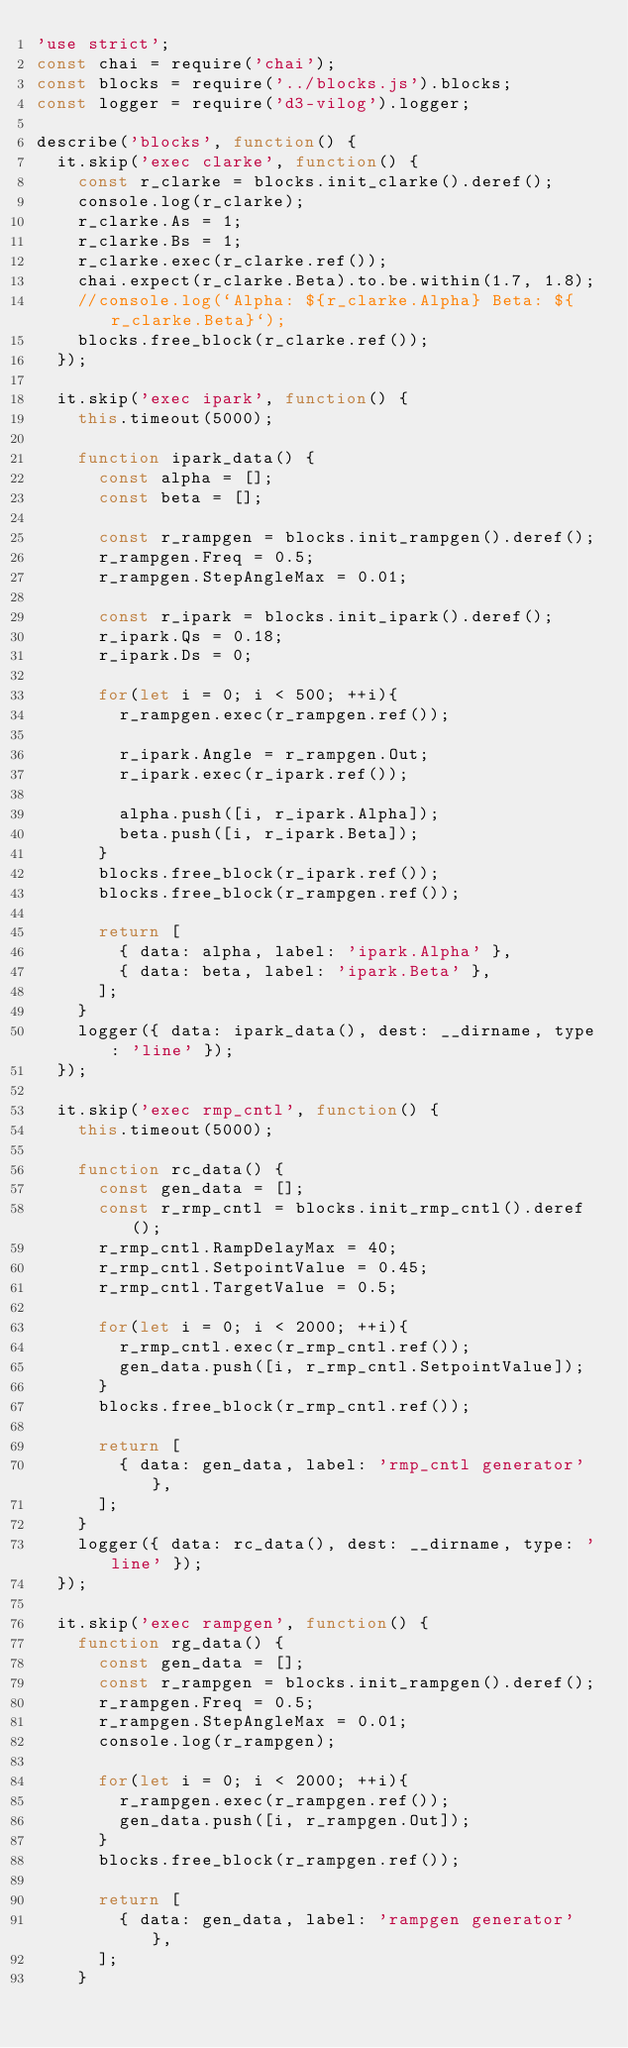<code> <loc_0><loc_0><loc_500><loc_500><_JavaScript_>'use strict';
const chai = require('chai');
const blocks = require('../blocks.js').blocks;
const logger = require('d3-vilog').logger;

describe('blocks', function() {
  it.skip('exec clarke', function() {
    const r_clarke = blocks.init_clarke().deref();
    console.log(r_clarke);
    r_clarke.As = 1;
    r_clarke.Bs = 1;
    r_clarke.exec(r_clarke.ref());
    chai.expect(r_clarke.Beta).to.be.within(1.7, 1.8);
    //console.log(`Alpha: ${r_clarke.Alpha} Beta: ${r_clarke.Beta}`);
    blocks.free_block(r_clarke.ref());
  });

  it.skip('exec ipark', function() {
    this.timeout(5000);

    function ipark_data() {
      const alpha = [];
      const beta = [];

      const r_rampgen = blocks.init_rampgen().deref();
      r_rampgen.Freq = 0.5;
      r_rampgen.StepAngleMax = 0.01;

      const r_ipark = blocks.init_ipark().deref();
      r_ipark.Qs = 0.18;
      r_ipark.Ds = 0;

      for(let i = 0; i < 500; ++i){
        r_rampgen.exec(r_rampgen.ref());

        r_ipark.Angle = r_rampgen.Out;
        r_ipark.exec(r_ipark.ref());

        alpha.push([i, r_ipark.Alpha]);
        beta.push([i, r_ipark.Beta]);
      }
      blocks.free_block(r_ipark.ref());
      blocks.free_block(r_rampgen.ref());

      return [
        { data: alpha, label: 'ipark.Alpha' },
        { data: beta, label: 'ipark.Beta' },
      ];
    }
    logger({ data: ipark_data(), dest: __dirname, type: 'line' });
  });

  it.skip('exec rmp_cntl', function() {
    this.timeout(5000);

    function rc_data() {
      const gen_data = [];
      const r_rmp_cntl = blocks.init_rmp_cntl().deref();
      r_rmp_cntl.RampDelayMax = 40;
      r_rmp_cntl.SetpointValue = 0.45;
      r_rmp_cntl.TargetValue = 0.5;

      for(let i = 0; i < 2000; ++i){
        r_rmp_cntl.exec(r_rmp_cntl.ref());
        gen_data.push([i, r_rmp_cntl.SetpointValue]);
      }
      blocks.free_block(r_rmp_cntl.ref());

      return [
        { data: gen_data, label: 'rmp_cntl generator' },
      ];
    }
    logger({ data: rc_data(), dest: __dirname, type: 'line' });
  });

  it.skip('exec rampgen', function() {
    function rg_data() {
      const gen_data = [];
      const r_rampgen = blocks.init_rampgen().deref();
      r_rampgen.Freq = 0.5;
      r_rampgen.StepAngleMax = 0.01;
      console.log(r_rampgen);

      for(let i = 0; i < 2000; ++i){
        r_rampgen.exec(r_rampgen.ref());
        gen_data.push([i, r_rampgen.Out]);
      }
      blocks.free_block(r_rampgen.ref());

      return [
        { data: gen_data, label: 'rampgen generator' },
      ];
    }</code> 